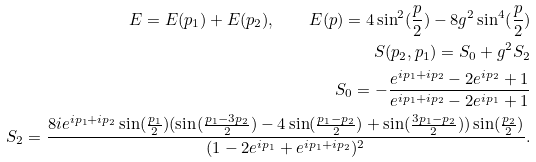Convert formula to latex. <formula><loc_0><loc_0><loc_500><loc_500>E = E ( p _ { 1 } ) + E ( p _ { 2 } ) , \quad E ( p ) = 4 \sin ^ { 2 } ( \frac { p } { 2 } ) - 8 g ^ { 2 } \sin ^ { 4 } ( \frac { p } { 2 } ) \\ S ( p _ { 2 } , p _ { 1 } ) = S _ { 0 } + g ^ { 2 } S _ { 2 } \\ S _ { 0 } = - \frac { e ^ { i p _ { 1 } + i p _ { 2 } } - 2 e ^ { i p _ { 2 } } + 1 } { e ^ { i p _ { 1 } + i p _ { 2 } } - 2 e ^ { i p _ { 1 } } + 1 } \\ S _ { 2 } = \frac { 8 i e ^ { i p _ { 1 } + i p _ { 2 } } \sin ( \frac { p _ { 1 } } { 2 } ) ( \sin ( \frac { p _ { 1 } - 3 p _ { 2 } } { 2 } ) - 4 \sin ( \frac { p _ { 1 } - p _ { 2 } } { 2 } ) + \sin ( \frac { 3 p _ { 1 } - p _ { 2 } } { 2 } ) ) \sin ( \frac { p _ { 2 } } { 2 } ) } { ( 1 - 2 e ^ { i p _ { 1 } } + e ^ { i p _ { 1 } + i p _ { 2 } } ) ^ { 2 } } .</formula> 